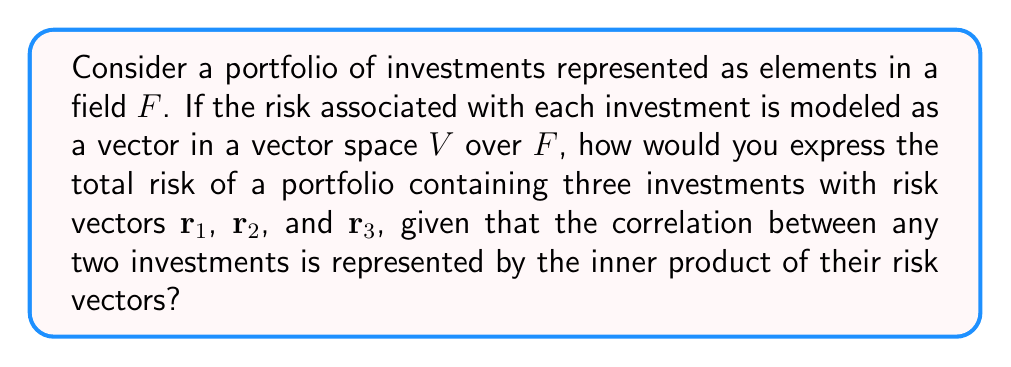Can you answer this question? To solve this problem, we'll follow these steps:

1) In field theory, vector addition represents the combination of risks. The total risk vector $\mathbf{R}$ is the sum of individual risk vectors:

   $$\mathbf{R} = \mathbf{r}_1 + \mathbf{r}_2 + \mathbf{r}_3$$

2) The magnitude of the total risk is given by the inner product of $\mathbf{R}$ with itself:

   $$\|\mathbf{R}\|^2 = \langle \mathbf{R}, \mathbf{R} \rangle$$

3) Expanding this using the properties of inner products:

   $$\|\mathbf{R}\|^2 = \langle \mathbf{r}_1 + \mathbf{r}_2 + \mathbf{r}_3, \mathbf{r}_1 + \mathbf{r}_2 + \mathbf{r}_3 \rangle$$

4) Using the bilinearity of inner products:

   $$\|\mathbf{R}\|^2 = \langle \mathbf{r}_1, \mathbf{r}_1 \rangle + \langle \mathbf{r}_1, \mathbf{r}_2 \rangle + \langle \mathbf{r}_1, \mathbf{r}_3 \rangle + 
                        \langle \mathbf{r}_2, \mathbf{r}_1 \rangle + \langle \mathbf{r}_2, \mathbf{r}_2 \rangle + \langle \mathbf{r}_2, \mathbf{r}_3 \rangle +
                        \langle \mathbf{r}_3, \mathbf{r}_1 \rangle + \langle \mathbf{r}_3, \mathbf{r}_2 \rangle + \langle \mathbf{r}_3, \mathbf{r}_3 \rangle$$

5) Since inner products are symmetric, $\langle \mathbf{r}_i, \mathbf{r}_j \rangle = \langle \mathbf{r}_j, \mathbf{r}_i \rangle$, we can simplify:

   $$\|\mathbf{R}\|^2 = \|\mathbf{r}_1\|^2 + \|\mathbf{r}_2\|^2 + \|\mathbf{r}_3\|^2 + 2(\langle \mathbf{r}_1, \mathbf{r}_2 \rangle + \langle \mathbf{r}_1, \mathbf{r}_3 \rangle + \langle \mathbf{r}_2, \mathbf{r}_3 \rangle)$$

This expression represents the total risk of the portfolio, accounting for both individual risks and their correlations.
Answer: $$\|\mathbf{R}\|^2 = \|\mathbf{r}_1\|^2 + \|\mathbf{r}_2\|^2 + \|\mathbf{r}_3\|^2 + 2(\langle \mathbf{r}_1, \mathbf{r}_2 \rangle + \langle \mathbf{r}_1, \mathbf{r}_3 \rangle + \langle \mathbf{r}_2, \mathbf{r}_3 \rangle)$$ 